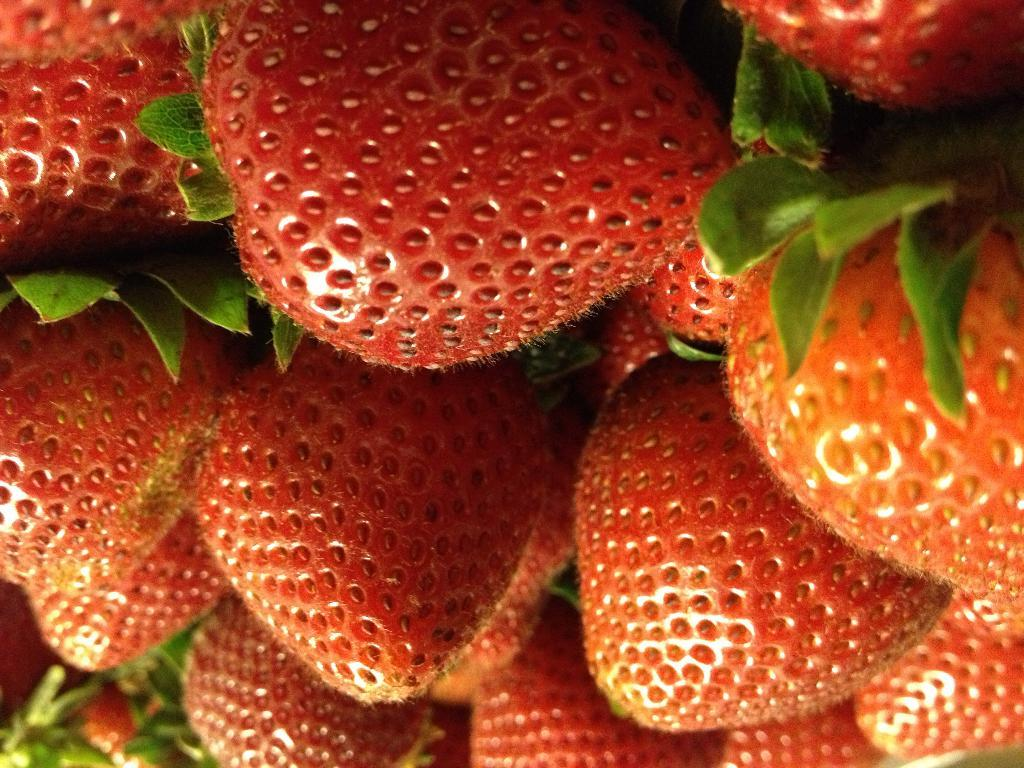What type of fruit is present in the image? There are strawberries in the image. What else can be seen in the image besides the strawberries? There are leaves in the image. What type of rice is being served in the cup in the image? There is no cup or rice present in the image; it only features strawberries and leaves. 